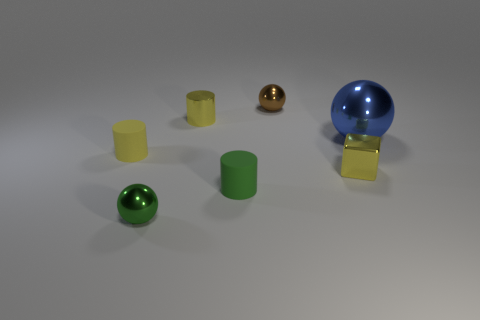Is the green metal ball the same size as the brown object?
Make the answer very short. Yes. There is a small matte cylinder that is right of the green object that is in front of the green rubber cylinder; what color is it?
Make the answer very short. Green. What is the color of the metal cylinder?
Offer a very short reply. Yellow. Are there any tiny metallic cubes that have the same color as the big metal object?
Make the answer very short. No. There is a ball in front of the big shiny thing; does it have the same color as the small shiny block?
Your response must be concise. No. What number of things are small shiny cylinders that are on the left side of the big blue shiny sphere or small metal cylinders?
Offer a very short reply. 1. There is a large metal ball; are there any tiny balls behind it?
Provide a succinct answer. Yes. There is a block that is the same color as the metal cylinder; what is it made of?
Keep it short and to the point. Metal. Is the material of the yellow cylinder that is left of the small green shiny object the same as the tiny brown sphere?
Provide a succinct answer. No. There is a tiny rubber object that is behind the small yellow object that is on the right side of the brown object; are there any tiny yellow shiny cylinders that are on the left side of it?
Make the answer very short. No. 